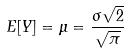Convert formula to latex. <formula><loc_0><loc_0><loc_500><loc_500>E [ Y ] = \mu = \frac { \sigma \sqrt { 2 } } { \sqrt { \pi } }</formula> 